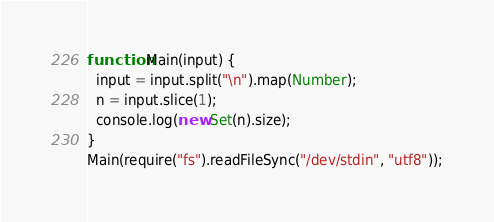Convert code to text. <code><loc_0><loc_0><loc_500><loc_500><_JavaScript_>function Main(input) {
  input = input.split("\n").map(Number);
  n = input.slice(1);
  console.log(new Set(n).size);
}
Main(require("fs").readFileSync("/dev/stdin", "utf8"));</code> 